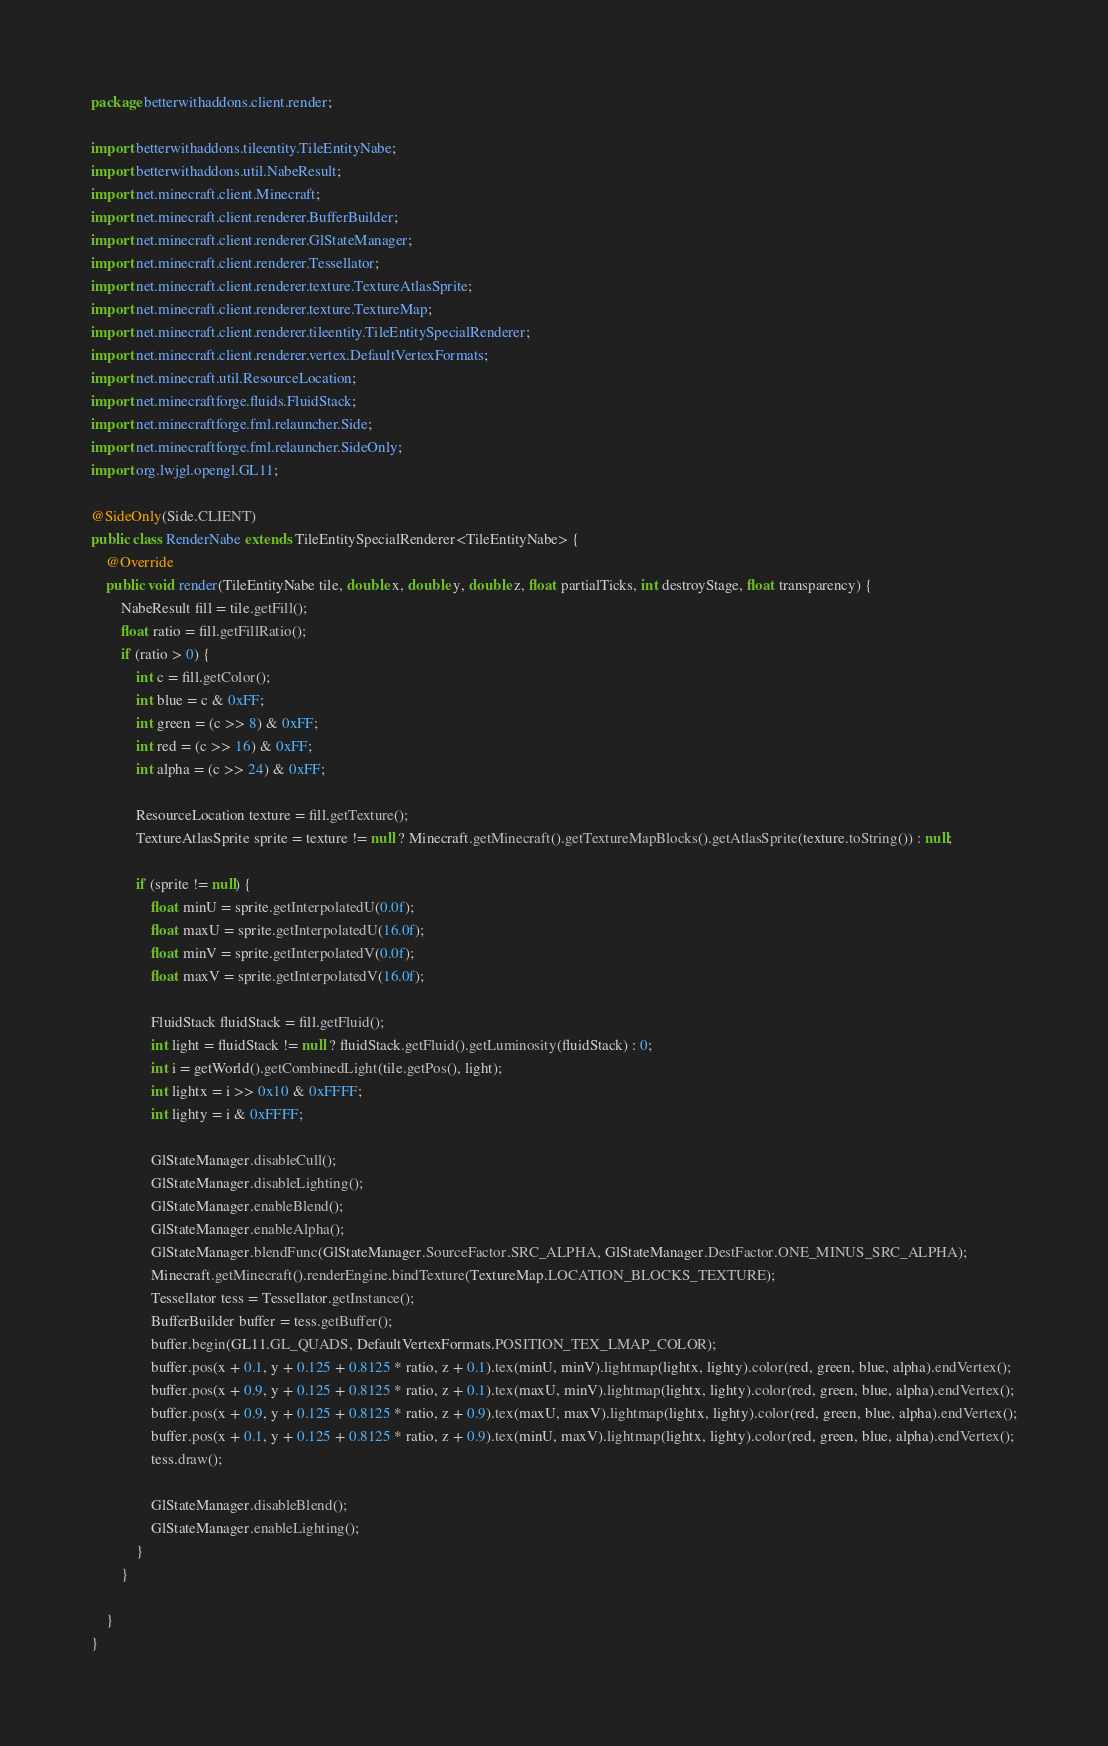<code> <loc_0><loc_0><loc_500><loc_500><_Java_>package betterwithaddons.client.render;

import betterwithaddons.tileentity.TileEntityNabe;
import betterwithaddons.util.NabeResult;
import net.minecraft.client.Minecraft;
import net.minecraft.client.renderer.BufferBuilder;
import net.minecraft.client.renderer.GlStateManager;
import net.minecraft.client.renderer.Tessellator;
import net.minecraft.client.renderer.texture.TextureAtlasSprite;
import net.minecraft.client.renderer.texture.TextureMap;
import net.minecraft.client.renderer.tileentity.TileEntitySpecialRenderer;
import net.minecraft.client.renderer.vertex.DefaultVertexFormats;
import net.minecraft.util.ResourceLocation;
import net.minecraftforge.fluids.FluidStack;
import net.minecraftforge.fml.relauncher.Side;
import net.minecraftforge.fml.relauncher.SideOnly;
import org.lwjgl.opengl.GL11;

@SideOnly(Side.CLIENT)
public class RenderNabe extends TileEntitySpecialRenderer<TileEntityNabe> {
    @Override
    public void render(TileEntityNabe tile, double x, double y, double z, float partialTicks, int destroyStage, float transparency) {
        NabeResult fill = tile.getFill();
        float ratio = fill.getFillRatio();
        if (ratio > 0) {
            int c = fill.getColor();
            int blue = c & 0xFF;
            int green = (c >> 8) & 0xFF;
            int red = (c >> 16) & 0xFF;
            int alpha = (c >> 24) & 0xFF;

            ResourceLocation texture = fill.getTexture();
            TextureAtlasSprite sprite = texture != null ? Minecraft.getMinecraft().getTextureMapBlocks().getAtlasSprite(texture.toString()) : null;

            if (sprite != null) {
                float minU = sprite.getInterpolatedU(0.0f);
                float maxU = sprite.getInterpolatedU(16.0f);
                float minV = sprite.getInterpolatedV(0.0f);
                float maxV = sprite.getInterpolatedV(16.0f);

                FluidStack fluidStack = fill.getFluid();
                int light = fluidStack != null ? fluidStack.getFluid().getLuminosity(fluidStack) : 0;
                int i = getWorld().getCombinedLight(tile.getPos(), light);
                int lightx = i >> 0x10 & 0xFFFF;
                int lighty = i & 0xFFFF;

                GlStateManager.disableCull();
                GlStateManager.disableLighting();
                GlStateManager.enableBlend();
                GlStateManager.enableAlpha();
                GlStateManager.blendFunc(GlStateManager.SourceFactor.SRC_ALPHA, GlStateManager.DestFactor.ONE_MINUS_SRC_ALPHA);
                Minecraft.getMinecraft().renderEngine.bindTexture(TextureMap.LOCATION_BLOCKS_TEXTURE);
                Tessellator tess = Tessellator.getInstance();
                BufferBuilder buffer = tess.getBuffer();
                buffer.begin(GL11.GL_QUADS, DefaultVertexFormats.POSITION_TEX_LMAP_COLOR);
                buffer.pos(x + 0.1, y + 0.125 + 0.8125 * ratio, z + 0.1).tex(minU, minV).lightmap(lightx, lighty).color(red, green, blue, alpha).endVertex();
                buffer.pos(x + 0.9, y + 0.125 + 0.8125 * ratio, z + 0.1).tex(maxU, minV).lightmap(lightx, lighty).color(red, green, blue, alpha).endVertex();
                buffer.pos(x + 0.9, y + 0.125 + 0.8125 * ratio, z + 0.9).tex(maxU, maxV).lightmap(lightx, lighty).color(red, green, blue, alpha).endVertex();
                buffer.pos(x + 0.1, y + 0.125 + 0.8125 * ratio, z + 0.9).tex(minU, maxV).lightmap(lightx, lighty).color(red, green, blue, alpha).endVertex();
                tess.draw();

                GlStateManager.disableBlend();
                GlStateManager.enableLighting();
            }
        }

    }
}
</code> 